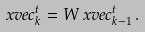Convert formula to latex. <formula><loc_0><loc_0><loc_500><loc_500>\ x v e c _ { k } ^ { t } & = W \ x v e c _ { k - 1 } ^ { t } \, .</formula> 